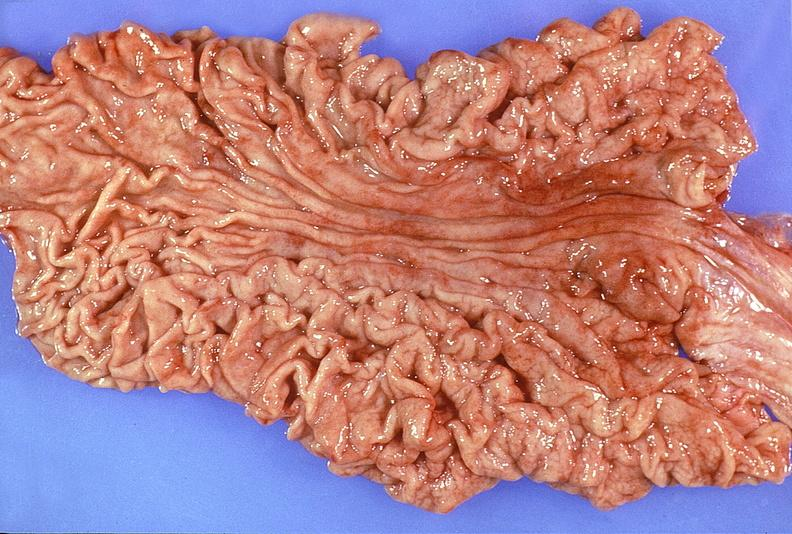what does this image show?
Answer the question using a single word or phrase. Normal stomach 